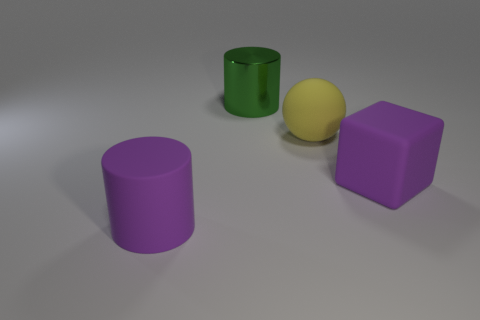Add 2 large cyan metallic spheres. How many objects exist? 6 Subtract all balls. How many objects are left? 3 Subtract all green things. Subtract all large yellow matte objects. How many objects are left? 2 Add 1 large green cylinders. How many large green cylinders are left? 2 Add 1 big green cylinders. How many big green cylinders exist? 2 Subtract 0 cyan blocks. How many objects are left? 4 